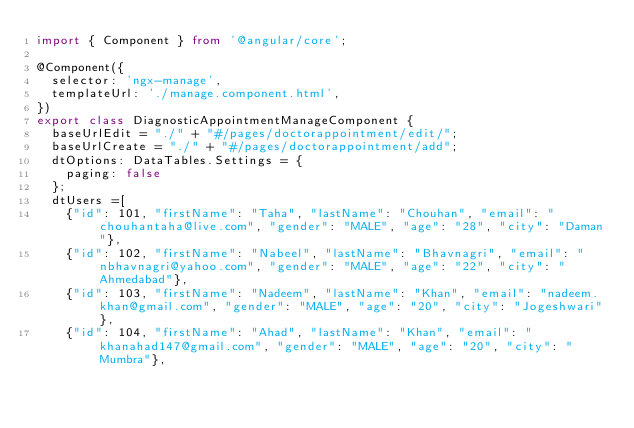<code> <loc_0><loc_0><loc_500><loc_500><_TypeScript_>import { Component } from '@angular/core';

@Component({
  selector: 'ngx-manage',
  templateUrl: './manage.component.html',
})
export class DiagnosticAppointmentManageComponent {
	baseUrlEdit = "./" + "#/pages/doctorappointment/edit/";
	baseUrlCreate = "./" + "#/pages/doctorappointment/add";
	dtOptions: DataTables.Settings = {
		paging: false
	};
  dtUsers =[
    {"id": 101, "firstName": "Taha", "lastName": "Chouhan", "email": "chouhantaha@live.com", "gender": "MALE", "age": "28", "city": "Daman"},
    {"id": 102, "firstName": "Nabeel", "lastName": "Bhavnagri", "email": "nbhavnagri@yahoo.com", "gender": "MALE", "age": "22", "city": "Ahmedabad"},
    {"id": 103, "firstName": "Nadeem", "lastName": "Khan", "email": "nadeem.khan@gmail.com", "gender": "MALE", "age": "20", "city": "Jogeshwari"},
    {"id": 104, "firstName": "Ahad", "lastName": "Khan", "email": "khanahad147@gmail.com", "gender": "MALE", "age": "20", "city": "Mumbra"},</code> 